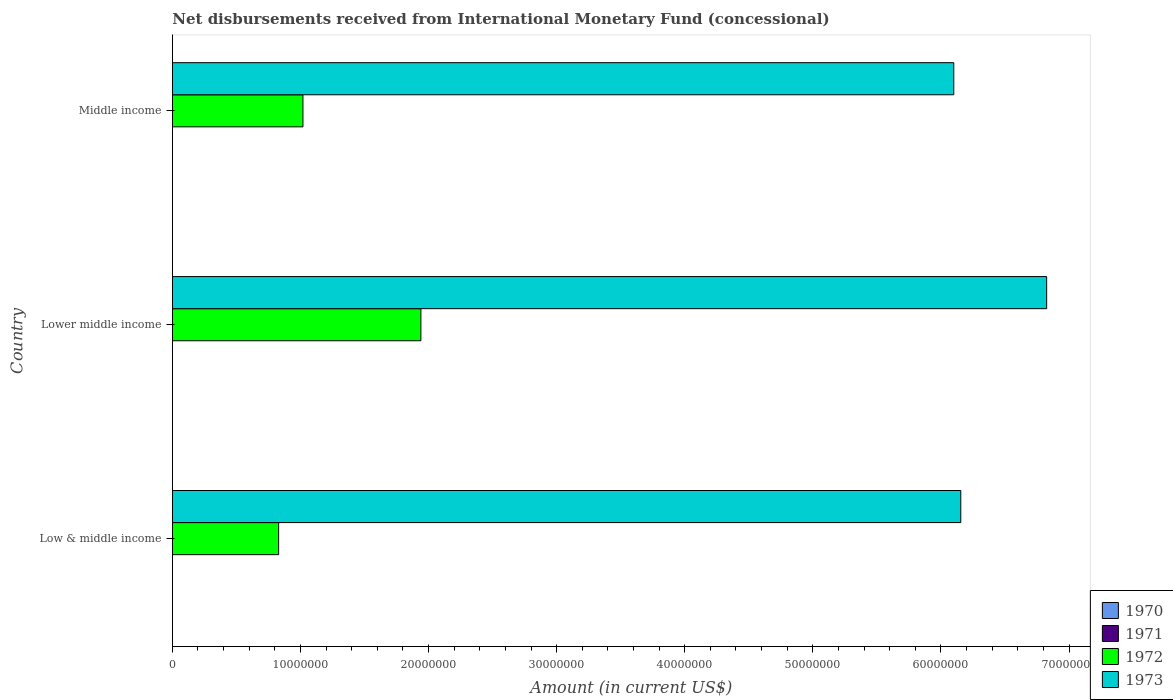Are the number of bars on each tick of the Y-axis equal?
Keep it short and to the point. Yes. How many bars are there on the 3rd tick from the top?
Keep it short and to the point. 2. What is the label of the 2nd group of bars from the top?
Offer a very short reply. Lower middle income. Across all countries, what is the maximum amount of disbursements received from International Monetary Fund in 1972?
Provide a short and direct response. 1.94e+07. Across all countries, what is the minimum amount of disbursements received from International Monetary Fund in 1973?
Offer a very short reply. 6.10e+07. In which country was the amount of disbursements received from International Monetary Fund in 1972 maximum?
Make the answer very short. Lower middle income. What is the total amount of disbursements received from International Monetary Fund in 1973 in the graph?
Offer a terse response. 1.91e+08. What is the difference between the amount of disbursements received from International Monetary Fund in 1972 in Low & middle income and that in Lower middle income?
Offer a very short reply. -1.11e+07. What is the difference between the amount of disbursements received from International Monetary Fund in 1973 in Lower middle income and the amount of disbursements received from International Monetary Fund in 1972 in Low & middle income?
Keep it short and to the point. 6.00e+07. What is the difference between the amount of disbursements received from International Monetary Fund in 1973 and amount of disbursements received from International Monetary Fund in 1972 in Lower middle income?
Provide a short and direct response. 4.89e+07. What is the ratio of the amount of disbursements received from International Monetary Fund in 1973 in Low & middle income to that in Lower middle income?
Offer a very short reply. 0.9. Is the amount of disbursements received from International Monetary Fund in 1973 in Low & middle income less than that in Middle income?
Give a very brief answer. No. What is the difference between the highest and the second highest amount of disbursements received from International Monetary Fund in 1972?
Make the answer very short. 9.21e+06. What is the difference between the highest and the lowest amount of disbursements received from International Monetary Fund in 1972?
Ensure brevity in your answer.  1.11e+07. Is the sum of the amount of disbursements received from International Monetary Fund in 1973 in Lower middle income and Middle income greater than the maximum amount of disbursements received from International Monetary Fund in 1970 across all countries?
Provide a succinct answer. Yes. Is it the case that in every country, the sum of the amount of disbursements received from International Monetary Fund in 1970 and amount of disbursements received from International Monetary Fund in 1972 is greater than the sum of amount of disbursements received from International Monetary Fund in 1973 and amount of disbursements received from International Monetary Fund in 1971?
Give a very brief answer. No. How many bars are there?
Give a very brief answer. 6. Are all the bars in the graph horizontal?
Give a very brief answer. Yes. How many countries are there in the graph?
Keep it short and to the point. 3. What is the difference between two consecutive major ticks on the X-axis?
Give a very brief answer. 1.00e+07. Does the graph contain grids?
Your answer should be very brief. No. Where does the legend appear in the graph?
Ensure brevity in your answer.  Bottom right. How are the legend labels stacked?
Offer a very short reply. Vertical. What is the title of the graph?
Ensure brevity in your answer.  Net disbursements received from International Monetary Fund (concessional). What is the Amount (in current US$) of 1972 in Low & middle income?
Offer a very short reply. 8.30e+06. What is the Amount (in current US$) of 1973 in Low & middle income?
Keep it short and to the point. 6.16e+07. What is the Amount (in current US$) in 1971 in Lower middle income?
Offer a very short reply. 0. What is the Amount (in current US$) in 1972 in Lower middle income?
Provide a short and direct response. 1.94e+07. What is the Amount (in current US$) of 1973 in Lower middle income?
Your answer should be very brief. 6.83e+07. What is the Amount (in current US$) of 1970 in Middle income?
Your answer should be compact. 0. What is the Amount (in current US$) in 1972 in Middle income?
Ensure brevity in your answer.  1.02e+07. What is the Amount (in current US$) in 1973 in Middle income?
Make the answer very short. 6.10e+07. Across all countries, what is the maximum Amount (in current US$) of 1972?
Give a very brief answer. 1.94e+07. Across all countries, what is the maximum Amount (in current US$) in 1973?
Provide a succinct answer. 6.83e+07. Across all countries, what is the minimum Amount (in current US$) in 1972?
Your response must be concise. 8.30e+06. Across all countries, what is the minimum Amount (in current US$) of 1973?
Your answer should be very brief. 6.10e+07. What is the total Amount (in current US$) in 1971 in the graph?
Ensure brevity in your answer.  0. What is the total Amount (in current US$) in 1972 in the graph?
Your response must be concise. 3.79e+07. What is the total Amount (in current US$) in 1973 in the graph?
Provide a succinct answer. 1.91e+08. What is the difference between the Amount (in current US$) of 1972 in Low & middle income and that in Lower middle income?
Provide a succinct answer. -1.11e+07. What is the difference between the Amount (in current US$) in 1973 in Low & middle income and that in Lower middle income?
Offer a very short reply. -6.70e+06. What is the difference between the Amount (in current US$) in 1972 in Low & middle income and that in Middle income?
Offer a terse response. -1.90e+06. What is the difference between the Amount (in current US$) in 1973 in Low & middle income and that in Middle income?
Offer a very short reply. 5.46e+05. What is the difference between the Amount (in current US$) of 1972 in Lower middle income and that in Middle income?
Your answer should be compact. 9.21e+06. What is the difference between the Amount (in current US$) in 1973 in Lower middle income and that in Middle income?
Keep it short and to the point. 7.25e+06. What is the difference between the Amount (in current US$) in 1972 in Low & middle income and the Amount (in current US$) in 1973 in Lower middle income?
Offer a terse response. -6.00e+07. What is the difference between the Amount (in current US$) of 1972 in Low & middle income and the Amount (in current US$) of 1973 in Middle income?
Keep it short and to the point. -5.27e+07. What is the difference between the Amount (in current US$) in 1972 in Lower middle income and the Amount (in current US$) in 1973 in Middle income?
Your answer should be compact. -4.16e+07. What is the average Amount (in current US$) in 1971 per country?
Ensure brevity in your answer.  0. What is the average Amount (in current US$) of 1972 per country?
Ensure brevity in your answer.  1.26e+07. What is the average Amount (in current US$) in 1973 per country?
Your answer should be very brief. 6.36e+07. What is the difference between the Amount (in current US$) of 1972 and Amount (in current US$) of 1973 in Low & middle income?
Your answer should be very brief. -5.33e+07. What is the difference between the Amount (in current US$) in 1972 and Amount (in current US$) in 1973 in Lower middle income?
Offer a terse response. -4.89e+07. What is the difference between the Amount (in current US$) in 1972 and Amount (in current US$) in 1973 in Middle income?
Provide a succinct answer. -5.08e+07. What is the ratio of the Amount (in current US$) in 1972 in Low & middle income to that in Lower middle income?
Keep it short and to the point. 0.43. What is the ratio of the Amount (in current US$) of 1973 in Low & middle income to that in Lower middle income?
Make the answer very short. 0.9. What is the ratio of the Amount (in current US$) in 1972 in Low & middle income to that in Middle income?
Ensure brevity in your answer.  0.81. What is the ratio of the Amount (in current US$) of 1973 in Low & middle income to that in Middle income?
Make the answer very short. 1.01. What is the ratio of the Amount (in current US$) in 1972 in Lower middle income to that in Middle income?
Give a very brief answer. 1.9. What is the ratio of the Amount (in current US$) of 1973 in Lower middle income to that in Middle income?
Your response must be concise. 1.12. What is the difference between the highest and the second highest Amount (in current US$) in 1972?
Ensure brevity in your answer.  9.21e+06. What is the difference between the highest and the second highest Amount (in current US$) of 1973?
Offer a very short reply. 6.70e+06. What is the difference between the highest and the lowest Amount (in current US$) in 1972?
Offer a very short reply. 1.11e+07. What is the difference between the highest and the lowest Amount (in current US$) of 1973?
Your answer should be compact. 7.25e+06. 